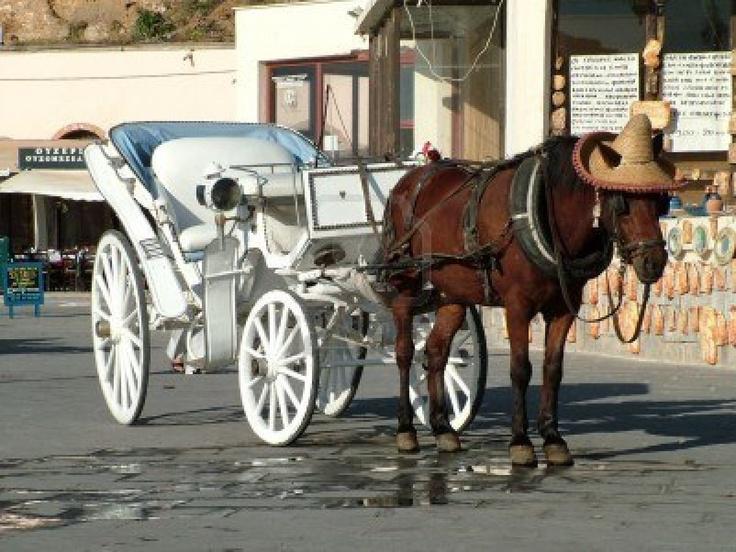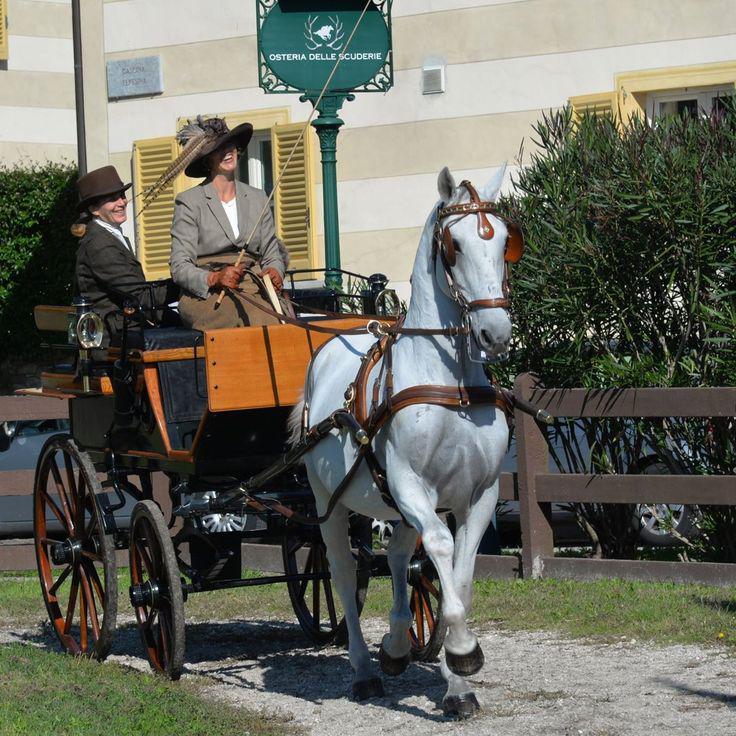The first image is the image on the left, the second image is the image on the right. Considering the images on both sides, is "An image shows a four-wheeled wagon pulled by more than one horse." valid? Answer yes or no. No. The first image is the image on the left, the second image is the image on the right. Assess this claim about the two images: "Teams of two horses are pulling the carriages.". Correct or not? Answer yes or no. No. 